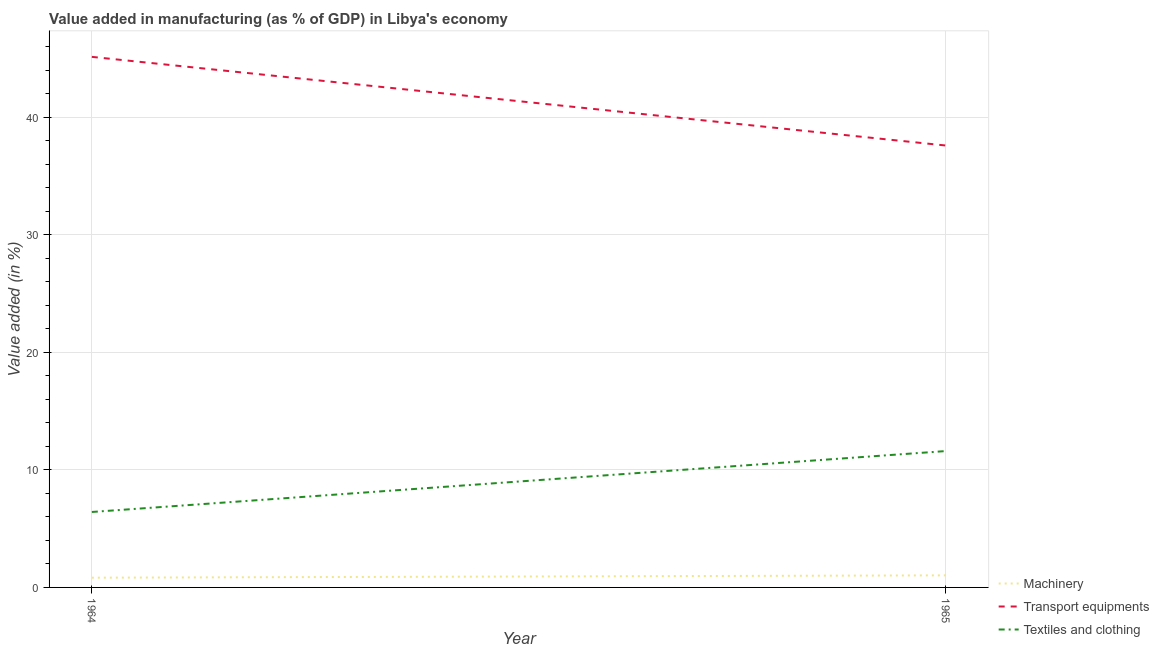How many different coloured lines are there?
Provide a succinct answer. 3. Is the number of lines equal to the number of legend labels?
Provide a succinct answer. Yes. What is the value added in manufacturing textile and clothing in 1964?
Your response must be concise. 6.42. Across all years, what is the maximum value added in manufacturing transport equipments?
Your response must be concise. 45.13. Across all years, what is the minimum value added in manufacturing transport equipments?
Provide a succinct answer. 37.59. In which year was the value added in manufacturing textile and clothing maximum?
Offer a very short reply. 1965. In which year was the value added in manufacturing textile and clothing minimum?
Your answer should be compact. 1964. What is the total value added in manufacturing transport equipments in the graph?
Your response must be concise. 82.73. What is the difference between the value added in manufacturing textile and clothing in 1964 and that in 1965?
Ensure brevity in your answer.  -5.18. What is the difference between the value added in manufacturing machinery in 1964 and the value added in manufacturing textile and clothing in 1965?
Give a very brief answer. -10.77. What is the average value added in manufacturing transport equipments per year?
Offer a very short reply. 41.36. In the year 1964, what is the difference between the value added in manufacturing transport equipments and value added in manufacturing textile and clothing?
Offer a terse response. 38.72. What is the ratio of the value added in manufacturing textile and clothing in 1964 to that in 1965?
Make the answer very short. 0.55. Is the value added in manufacturing transport equipments in 1964 less than that in 1965?
Give a very brief answer. No. In how many years, is the value added in manufacturing machinery greater than the average value added in manufacturing machinery taken over all years?
Keep it short and to the point. 1. Is the value added in manufacturing transport equipments strictly less than the value added in manufacturing machinery over the years?
Your response must be concise. No. What is the difference between two consecutive major ticks on the Y-axis?
Provide a succinct answer. 10. How many legend labels are there?
Give a very brief answer. 3. What is the title of the graph?
Ensure brevity in your answer.  Value added in manufacturing (as % of GDP) in Libya's economy. What is the label or title of the Y-axis?
Offer a very short reply. Value added (in %). What is the Value added (in %) of Machinery in 1964?
Give a very brief answer. 0.83. What is the Value added (in %) of Transport equipments in 1964?
Offer a very short reply. 45.13. What is the Value added (in %) in Textiles and clothing in 1964?
Offer a very short reply. 6.42. What is the Value added (in %) in Machinery in 1965?
Offer a very short reply. 1.03. What is the Value added (in %) of Transport equipments in 1965?
Offer a terse response. 37.59. What is the Value added (in %) in Textiles and clothing in 1965?
Your answer should be very brief. 11.6. Across all years, what is the maximum Value added (in %) in Machinery?
Offer a terse response. 1.03. Across all years, what is the maximum Value added (in %) of Transport equipments?
Give a very brief answer. 45.13. Across all years, what is the maximum Value added (in %) of Textiles and clothing?
Keep it short and to the point. 11.6. Across all years, what is the minimum Value added (in %) of Machinery?
Your answer should be very brief. 0.83. Across all years, what is the minimum Value added (in %) in Transport equipments?
Keep it short and to the point. 37.59. Across all years, what is the minimum Value added (in %) of Textiles and clothing?
Provide a succinct answer. 6.42. What is the total Value added (in %) in Machinery in the graph?
Offer a very short reply. 1.86. What is the total Value added (in %) of Transport equipments in the graph?
Provide a succinct answer. 82.73. What is the total Value added (in %) of Textiles and clothing in the graph?
Ensure brevity in your answer.  18.02. What is the difference between the Value added (in %) of Machinery in 1964 and that in 1965?
Your answer should be compact. -0.2. What is the difference between the Value added (in %) in Transport equipments in 1964 and that in 1965?
Provide a short and direct response. 7.54. What is the difference between the Value added (in %) of Textiles and clothing in 1964 and that in 1965?
Offer a very short reply. -5.18. What is the difference between the Value added (in %) in Machinery in 1964 and the Value added (in %) in Transport equipments in 1965?
Ensure brevity in your answer.  -36.76. What is the difference between the Value added (in %) in Machinery in 1964 and the Value added (in %) in Textiles and clothing in 1965?
Provide a succinct answer. -10.77. What is the difference between the Value added (in %) in Transport equipments in 1964 and the Value added (in %) in Textiles and clothing in 1965?
Your answer should be compact. 33.53. What is the average Value added (in %) in Machinery per year?
Ensure brevity in your answer.  0.93. What is the average Value added (in %) of Transport equipments per year?
Give a very brief answer. 41.36. What is the average Value added (in %) of Textiles and clothing per year?
Your answer should be compact. 9.01. In the year 1964, what is the difference between the Value added (in %) in Machinery and Value added (in %) in Transport equipments?
Ensure brevity in your answer.  -44.31. In the year 1964, what is the difference between the Value added (in %) of Machinery and Value added (in %) of Textiles and clothing?
Your response must be concise. -5.59. In the year 1964, what is the difference between the Value added (in %) of Transport equipments and Value added (in %) of Textiles and clothing?
Ensure brevity in your answer.  38.72. In the year 1965, what is the difference between the Value added (in %) of Machinery and Value added (in %) of Transport equipments?
Your response must be concise. -36.56. In the year 1965, what is the difference between the Value added (in %) in Machinery and Value added (in %) in Textiles and clothing?
Your answer should be compact. -10.57. In the year 1965, what is the difference between the Value added (in %) in Transport equipments and Value added (in %) in Textiles and clothing?
Your answer should be compact. 25.99. What is the ratio of the Value added (in %) in Machinery in 1964 to that in 1965?
Your answer should be very brief. 0.81. What is the ratio of the Value added (in %) of Transport equipments in 1964 to that in 1965?
Offer a very short reply. 1.2. What is the ratio of the Value added (in %) of Textiles and clothing in 1964 to that in 1965?
Your answer should be compact. 0.55. What is the difference between the highest and the second highest Value added (in %) of Machinery?
Ensure brevity in your answer.  0.2. What is the difference between the highest and the second highest Value added (in %) in Transport equipments?
Offer a very short reply. 7.54. What is the difference between the highest and the second highest Value added (in %) of Textiles and clothing?
Provide a short and direct response. 5.18. What is the difference between the highest and the lowest Value added (in %) in Machinery?
Your answer should be very brief. 0.2. What is the difference between the highest and the lowest Value added (in %) in Transport equipments?
Your response must be concise. 7.54. What is the difference between the highest and the lowest Value added (in %) in Textiles and clothing?
Keep it short and to the point. 5.18. 